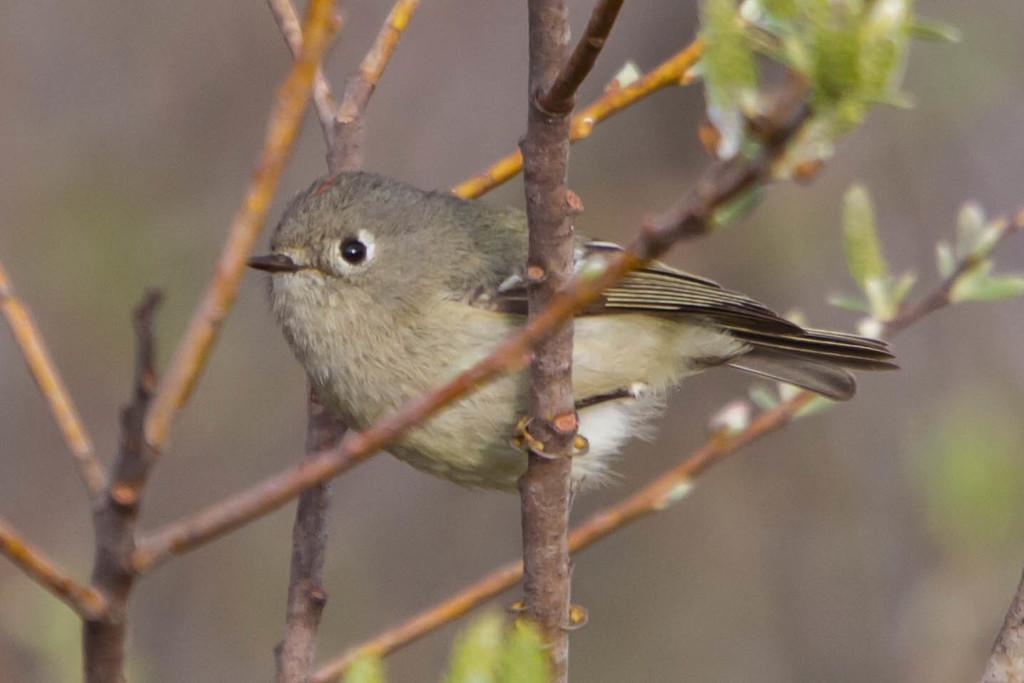Could you give a brief overview of what you see in this image? In this image I can see few green colour leaves, few stems and on it I can see a bird. I can also see this image is little bit blurry. 